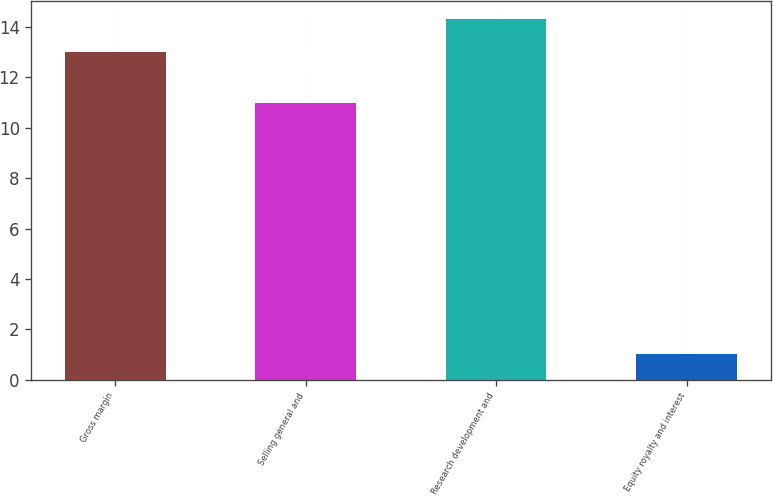Convert chart to OTSL. <chart><loc_0><loc_0><loc_500><loc_500><bar_chart><fcel>Gross margin<fcel>Selling general and<fcel>Research development and<fcel>Equity royalty and interest<nl><fcel>13<fcel>11<fcel>14.3<fcel>1<nl></chart> 